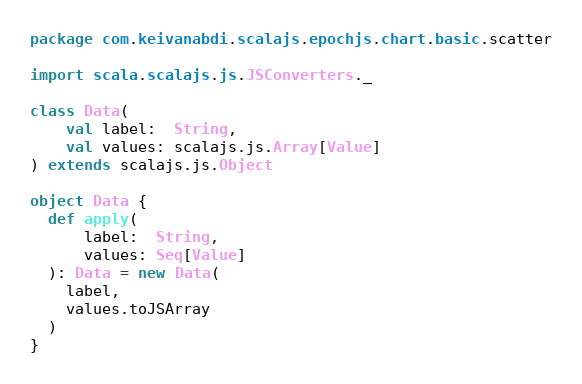<code> <loc_0><loc_0><loc_500><loc_500><_Scala_>package com.keivanabdi.scalajs.epochjs.chart.basic.scatter

import scala.scalajs.js.JSConverters._

class Data(
    val label:  String,
    val values: scalajs.js.Array[Value]
) extends scalajs.js.Object

object Data {
  def apply(
      label:  String,
      values: Seq[Value]
  ): Data = new Data(
    label,
    values.toJSArray
  )
}
</code> 